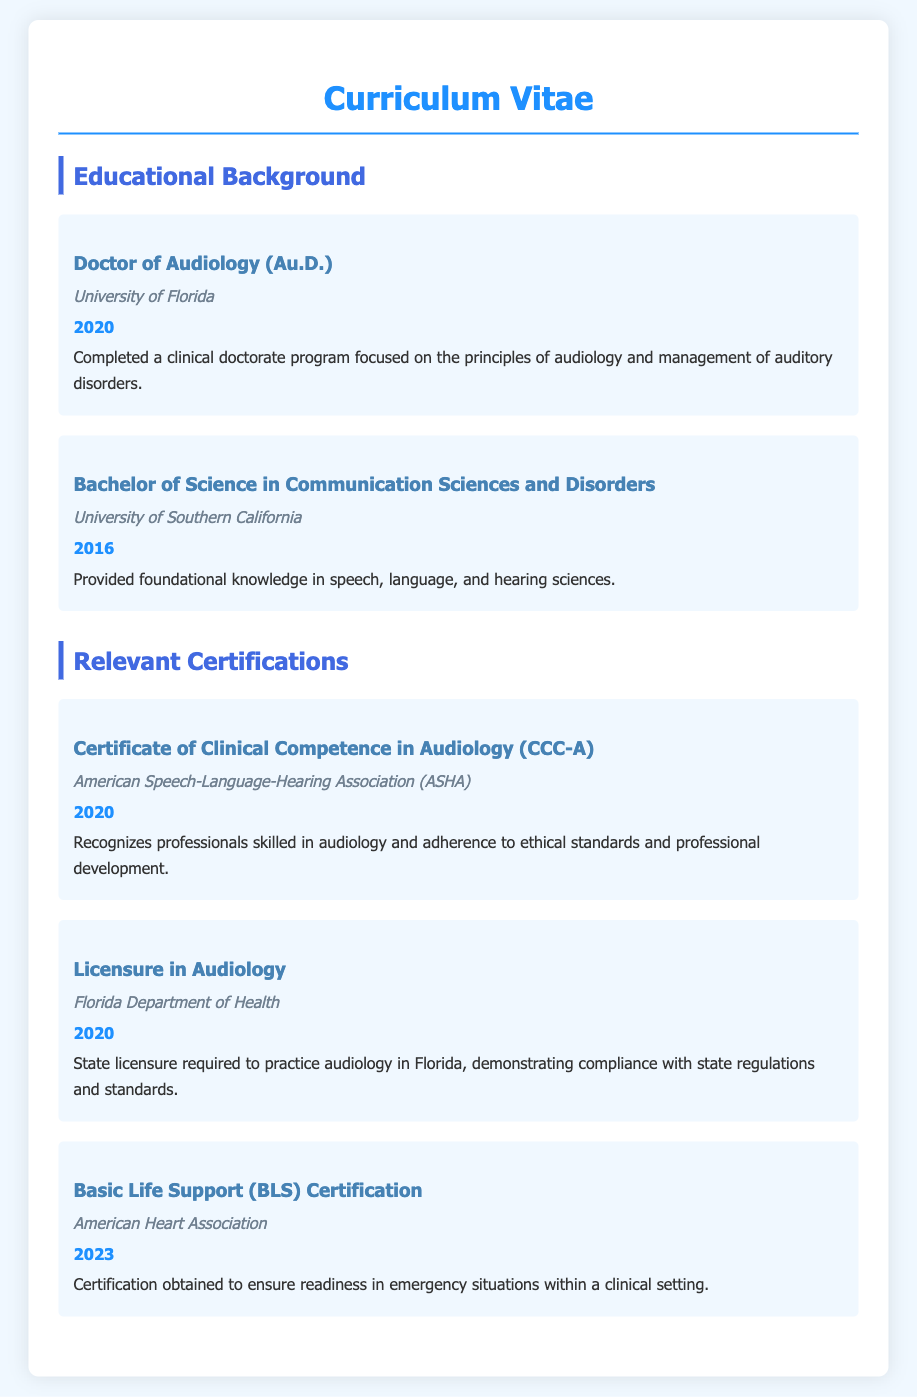What degree does the individual hold? The document lists the highest degree earned, which is a Doctor of Audiology (Au.D.).
Answer: Doctor of Audiology (Au.D.) Where did the individual complete their Bachelor of Science? The document provides the name of the institution where the bachelor's degree was earned.
Answer: University of Southern California In what year did the individual receive their Doctor of Audiology? The year associated with the completion of the Doctor of Audiology program is mentioned in the document.
Answer: 2020 What certification is recognized by ASHA? The document specifies a certification that has been awarded by a professional organization.
Answer: Certificate of Clinical Competence in Audiology (CCC-A) Which organization issued the Basic Life Support Certification? The document mentions the organization responsible for providing the BLS certification.
Answer: American Heart Association What is a requirement to practice audiology in Florida? The document refers to a specific licensure essential for practice in a certain state.
Answer: Licensure in Audiology How many relevant certifications are listed? The total number of certifications detailed in the document is requested.
Answer: Three What type of degree is a Doctor of Audiology? The document indicates that this degree is a specific kind of clinical doctorate.
Answer: Clinical doctorate Which degree provides foundational knowledge in speech, language, and hearing sciences? The document describes the purpose of a particular undergraduate degree.
Answer: Bachelor of Science in Communication Sciences and Disorders 